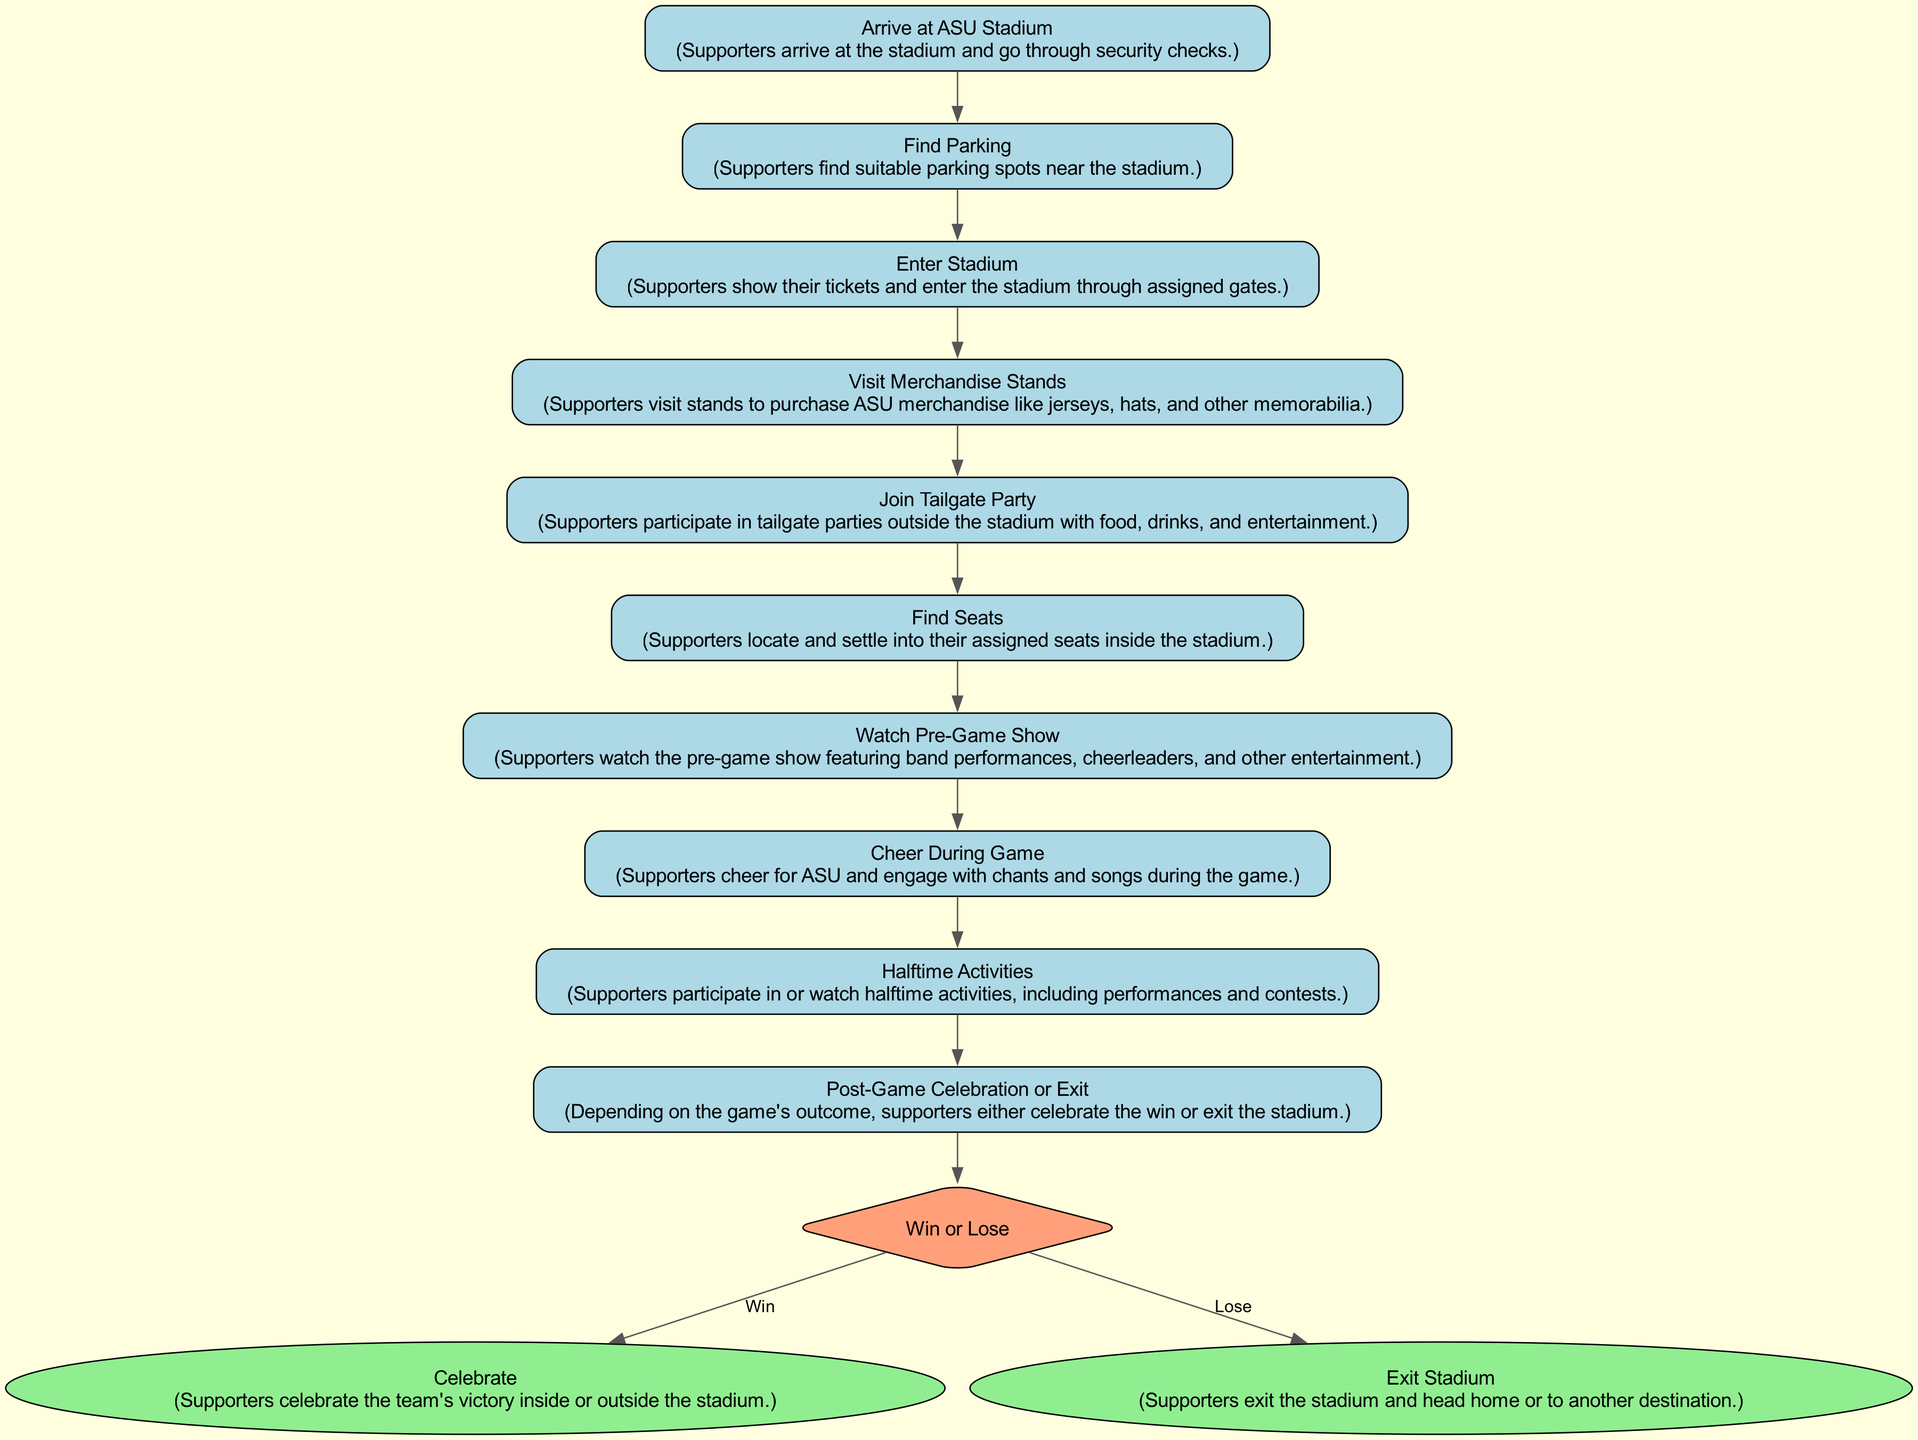What is the first activity a supporter engages in? The diagram shows that the first activity listed is "Arrive at ASU Stadium," indicating it is the starting point for supporters.
Answer: Arrive at ASU Stadium How many end activities are shown in the diagram? The diagram contains two end activities: "Celebrate" and "Exit Stadium," which are represented as final steps after the decision point.
Answer: 2 What activity directly follows "Join Tailgate Party"? The next activity listed after "Join Tailgate Party" in the sequence is "Find Seats," indicating the order of activities for supporters.
Answer: Find Seats What decision do supporters face after "Halftime Activities"? The supporters face the decision point "Win or Lose" after "Halftime Activities," which determines their subsequent actions based on the game's outcome.
Answer: Win or Lose If the decision is "Lose," what is the next activity? Following the decision of "Lose," the next activity represented in the diagram is "Exit Stadium," indicating what supporters do if the game result is unfavorable.
Answer: Exit Stadium What is the relationship between "Cheer During Game" and "Halftime Activities"? "Cheer During Game" follows "Halftime Activities" in the sequence, indicating that supporters engage in cheering after participating in or watching halftime activities.
Answer: Cheer During Game Which actor is involved in all activities in the diagram? The actor involved in all listed activities in the diagram is the "Supporter," as they are the ones performing each activity.
Answer: Supporter How many activities occur before reaching the decision point? There are eight activities detailed before the diagram reaches the decision point "Win or Lose," illustrating the sequence of events leading to that moment.
Answer: 8 